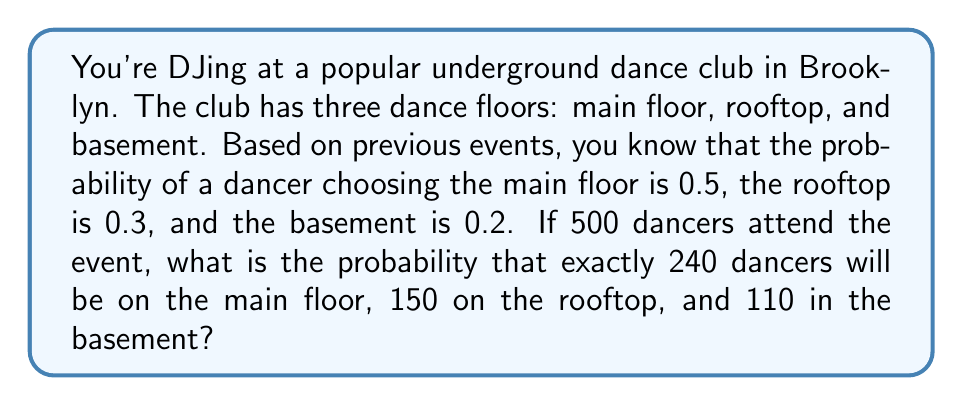What is the answer to this math problem? To solve this problem, we'll use the multinomial distribution, which is an extension of the binomial distribution for scenarios with more than two outcomes.

The probability mass function for the multinomial distribution is:

$$P(X_1 = k_1, X_2 = k_2, ..., X_m = k_m) = \frac{n!}{k_1! k_2! ... k_m!} p_1^{k_1} p_2^{k_2} ... p_m^{k_m}$$

Where:
- $n$ is the total number of trials (dancers in this case)
- $k_i$ is the number of occurrences of outcome $i$
- $p_i$ is the probability of outcome $i$

For our problem:
- $n = 500$ (total number of dancers)
- $k_1 = 240$ (main floor), $k_2 = 150$ (rooftop), $k_3 = 110$ (basement)
- $p_1 = 0.5$ (main floor), $p_2 = 0.3$ (rooftop), $p_3 = 0.2$ (basement)

Let's substitute these values into the formula:

$$P(X_1 = 240, X_2 = 150, X_3 = 110) = \frac{500!}{240! 150! 110!} 0.5^{240} 0.3^{150} 0.2^{110}$$

Now, let's calculate this step by step:

1. Calculate the factorial term:
   $\frac{500!}{240! 150! 110!} \approx 1.7409 \times 10^{89}$

2. Calculate the probability terms:
   $0.5^{240} \approx 8.2718 \times 10^{-73}$
   $0.3^{150} \approx 1.5230 \times 10^{-76}$
   $0.2^{110} \approx 1.0486 \times 10^{-71}$

3. Multiply all terms:
   $1.7409 \times 10^{89} \times 8.2718 \times 10^{-73} \times 1.5230 \times 10^{-76} \times 1.0486 \times 10^{-71} \approx 0.0224$

Therefore, the probability of exactly 240 dancers on the main floor, 150 on the rooftop, and 110 in the basement is approximately 0.0224 or 2.24%.
Answer: The probability is approximately 0.0224 or 2.24%. 